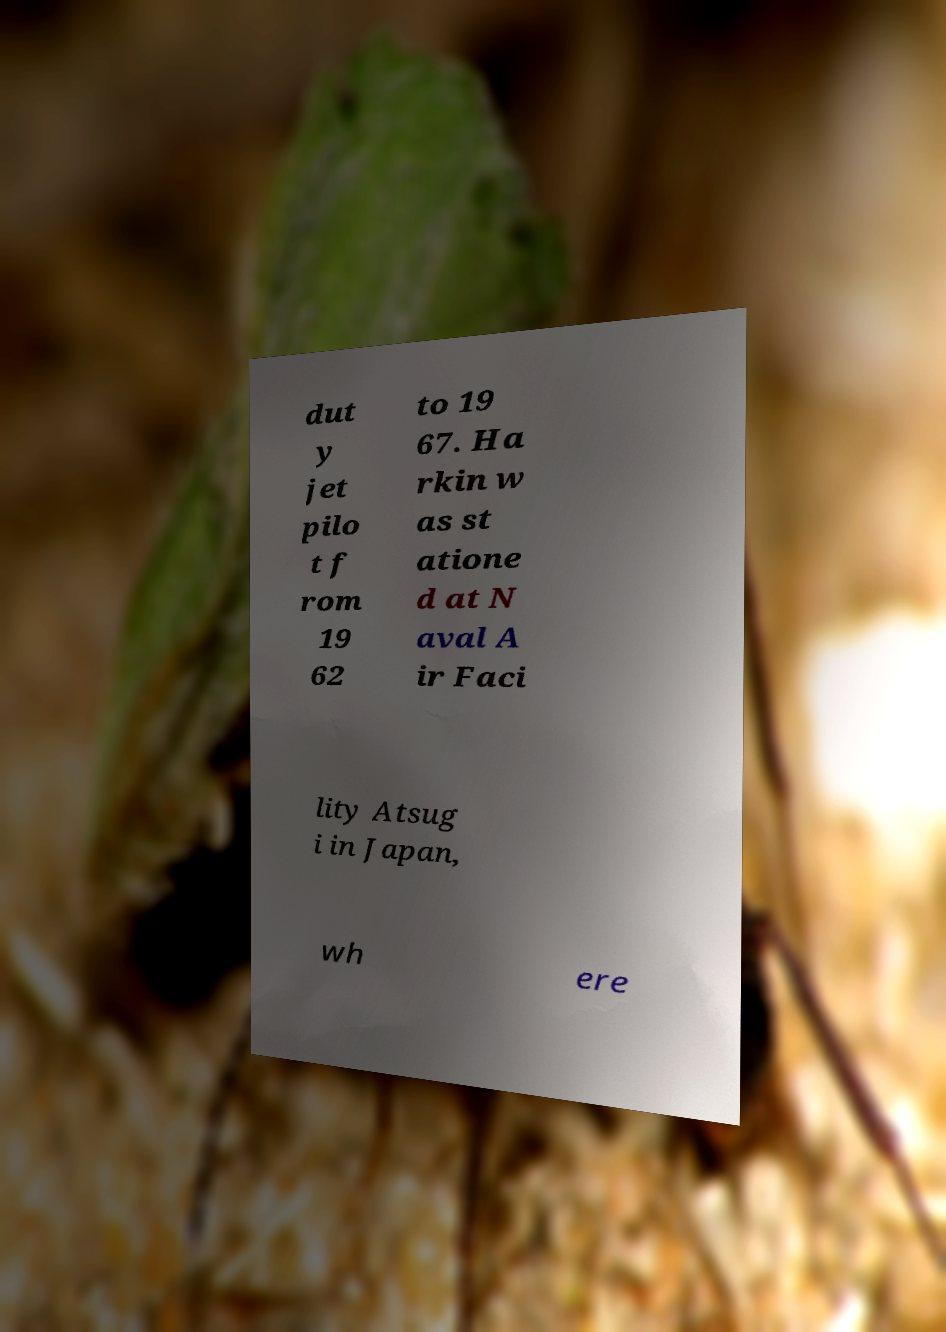I need the written content from this picture converted into text. Can you do that? dut y jet pilo t f rom 19 62 to 19 67. Ha rkin w as st atione d at N aval A ir Faci lity Atsug i in Japan, wh ere 